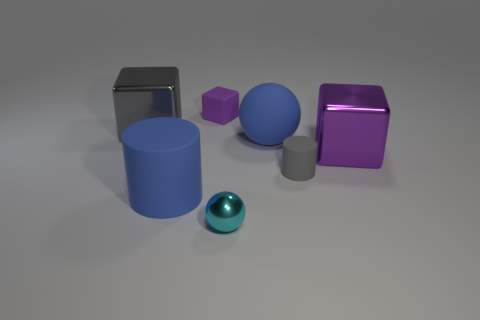There is a cylinder that is the same color as the large ball; what is its material?
Make the answer very short. Rubber. What is the tiny object that is both on the left side of the small gray cylinder and behind the blue cylinder made of?
Ensure brevity in your answer.  Rubber. What is the color of the other matte object that is the same shape as the big purple object?
Your response must be concise. Purple. There is a block in front of the gray cube; is there a big cube that is to the left of it?
Your answer should be very brief. Yes. The purple rubber block is what size?
Your answer should be compact. Small. What shape is the tiny thing that is in front of the big gray metal object and behind the large cylinder?
Your answer should be compact. Cylinder. How many purple things are either big things or large matte objects?
Your response must be concise. 1. Does the gray object behind the big ball have the same size as the block in front of the big blue ball?
Ensure brevity in your answer.  Yes. What number of things are either big gray rubber cubes or cylinders?
Give a very brief answer. 2. Are there any large blue things of the same shape as the tiny cyan metallic object?
Keep it short and to the point. Yes. 